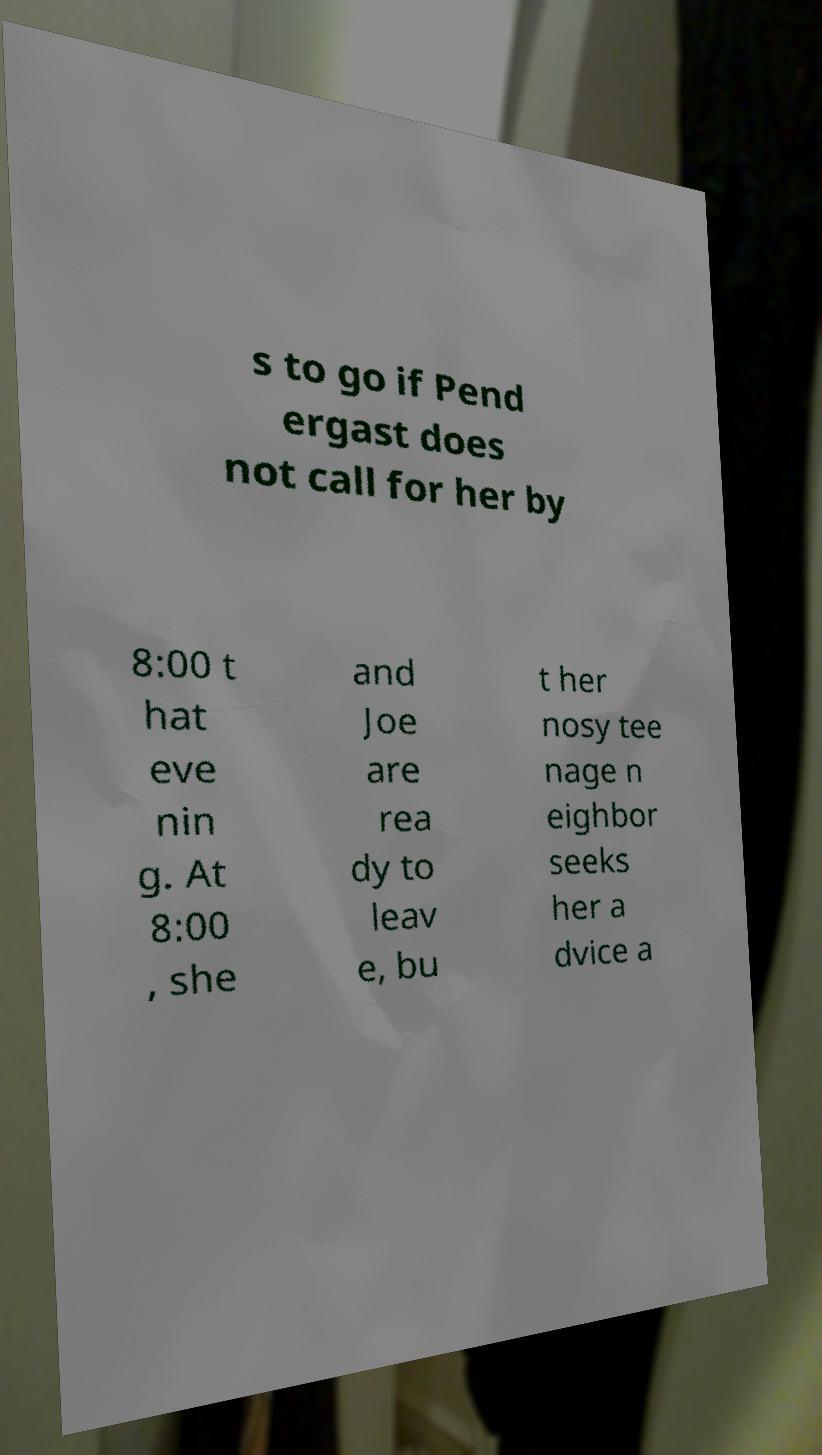Could you extract and type out the text from this image? s to go if Pend ergast does not call for her by 8:00 t hat eve nin g. At 8:00 , she and Joe are rea dy to leav e, bu t her nosy tee nage n eighbor seeks her a dvice a 